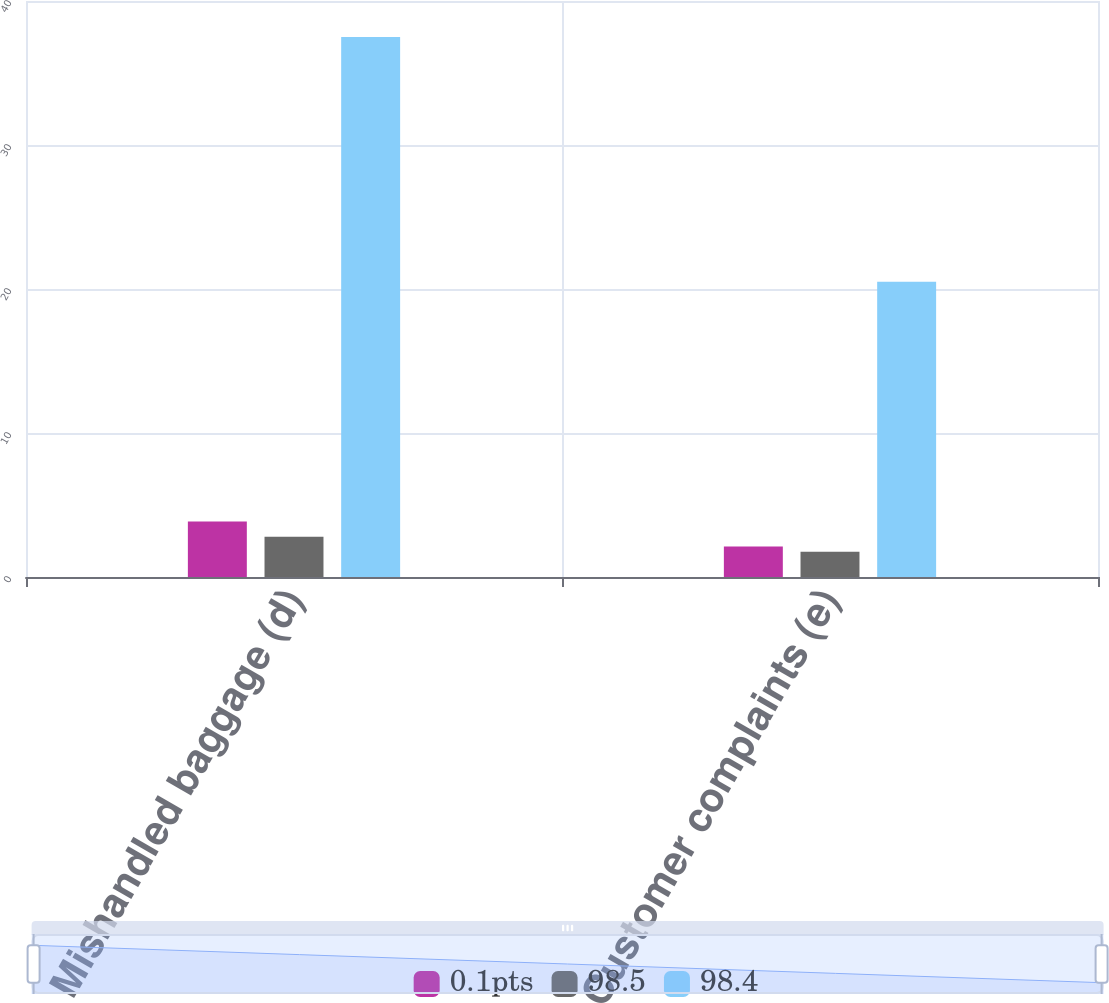<chart> <loc_0><loc_0><loc_500><loc_500><stacked_bar_chart><ecel><fcel>Mishandled baggage (d)<fcel>Customer complaints (e)<nl><fcel>0.1pts<fcel>3.85<fcel>2.12<nl><fcel>98.5<fcel>2.8<fcel>1.76<nl><fcel>98.4<fcel>37.5<fcel>20.5<nl></chart> 